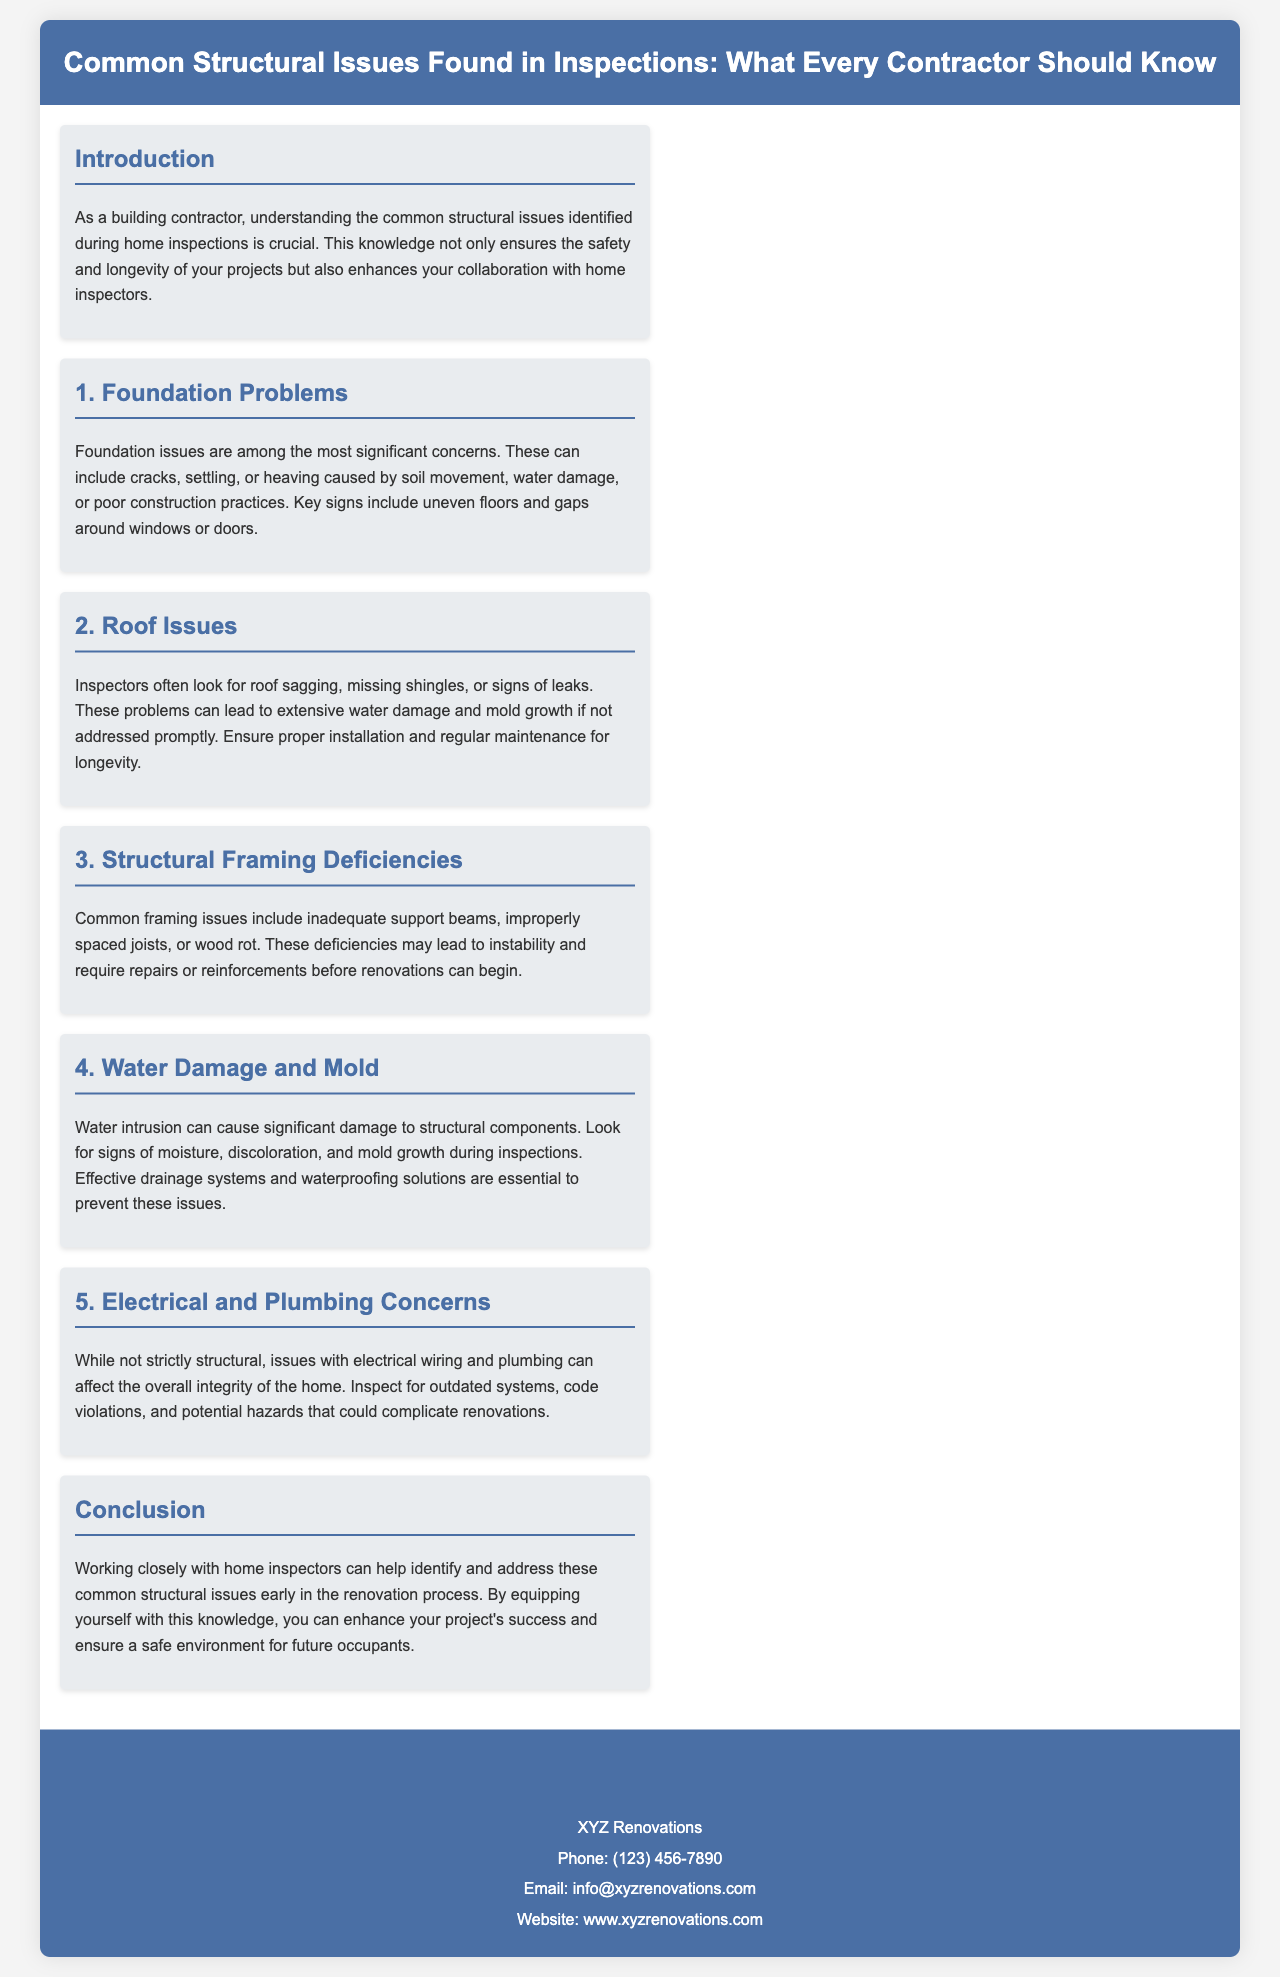what is the title of the brochure? The title of the brochure is prominently displayed in the header section, providing the main topic of discussion for contractors.
Answer: Common Structural Issues Found in Inspections: What Every Contractor Should Know what are the main structural issues discussed? The brochure outlines specific structural issues, categorized into distinct sections, which are listed in order.
Answer: Foundation Problems, Roof Issues, Structural Framing Deficiencies, Water Damage and Mold, Electrical and Plumbing Concerns how many sections detail specific structural issues? The brochure contains sections that each focus on a different structural issue.
Answer: 5 where can you find contact information? The contact information is presented in its own section towards the end of the brochure, making it easy for readers to find.
Answer: Contact Us what is suggested to prevent water damage? The document suggests preventive measures essential to avoid significant structural issues caused by moisture.
Answer: Effective drainage systems and waterproofing solutions what is the main benefit of working with home inspectors? The conclusion of the brochure emphasizes the advantages of collaboration with home inspectors for contractors.
Answer: Identify and address common structural issues early what color is the header background? The header of the brochure features a specific color scheme highlighted in the design.
Answer: #4a6fa5 